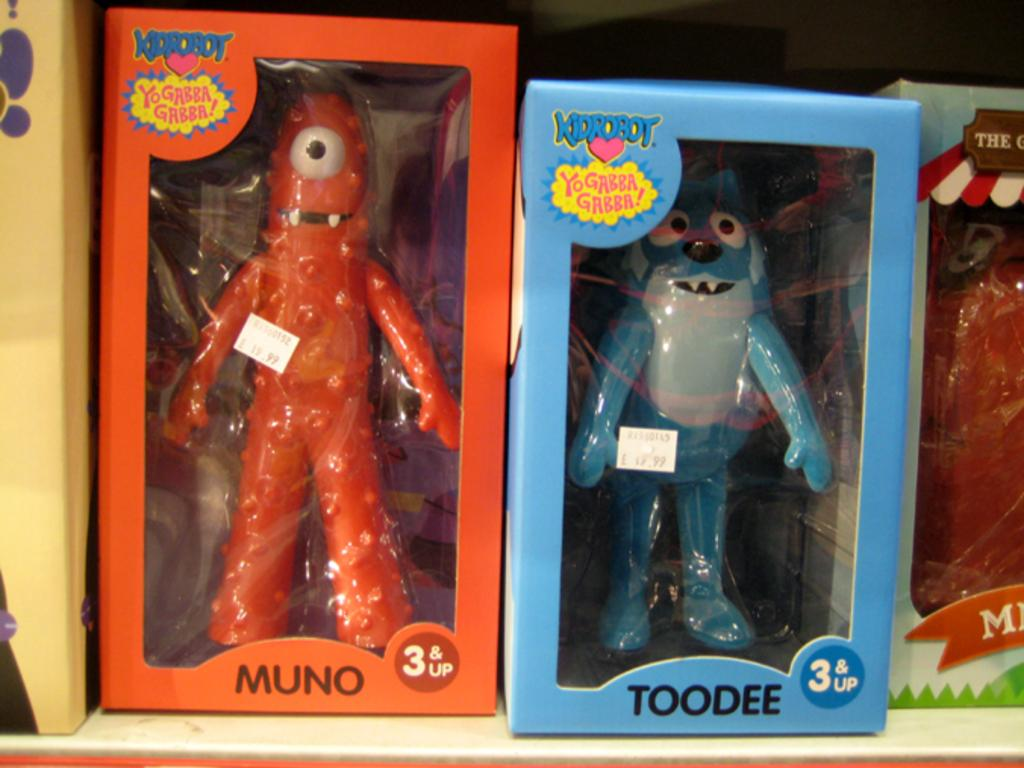What objects are present in the image? There are toys in the image. How are the toys organized in the image? The toys are in different boxes. What can be observed about the boxes in the image? The boxes are in different colors. Where is the vase located in the image? There is no vase present in the image. What type of apple can be seen in the image? There is no apple present in the image. 